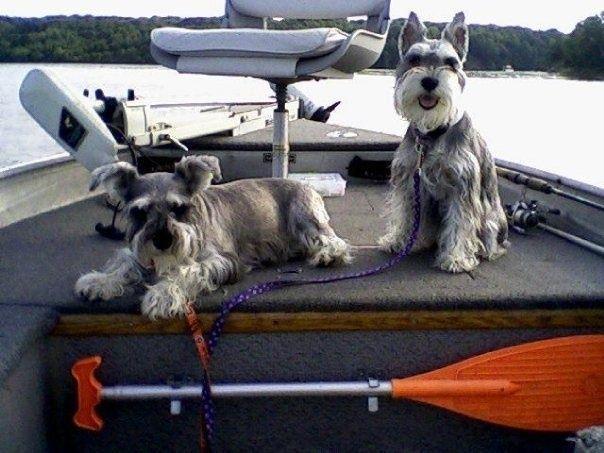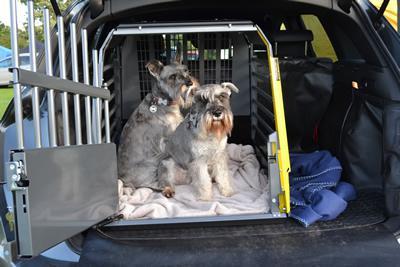The first image is the image on the left, the second image is the image on the right. For the images displayed, is the sentence "There is a black dog in both images." factually correct? Answer yes or no. No. The first image is the image on the left, the second image is the image on the right. Assess this claim about the two images: "there is no more then four dogs". Correct or not? Answer yes or no. Yes. 